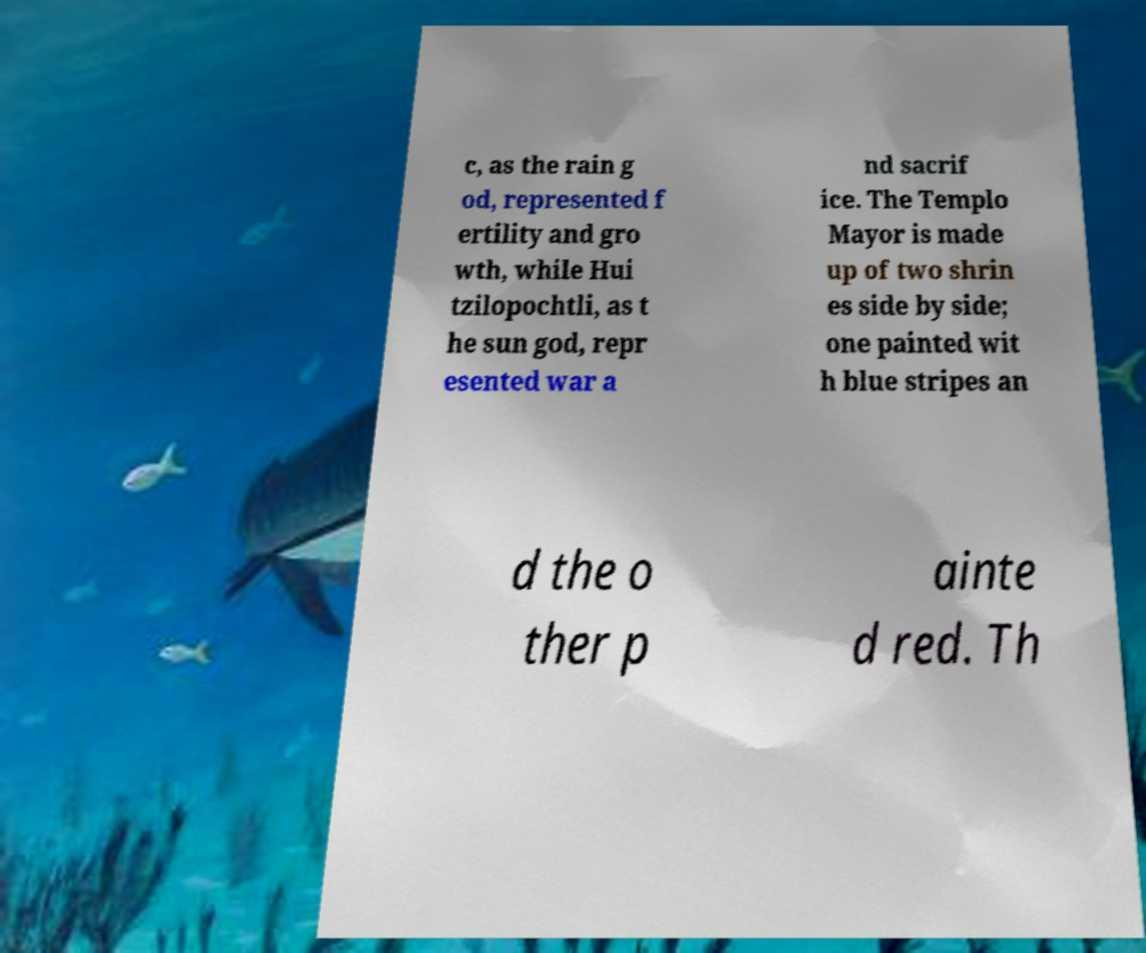There's text embedded in this image that I need extracted. Can you transcribe it verbatim? c, as the rain g od, represented f ertility and gro wth, while Hui tzilopochtli, as t he sun god, repr esented war a nd sacrif ice. The Templo Mayor is made up of two shrin es side by side; one painted wit h blue stripes an d the o ther p ainte d red. Th 